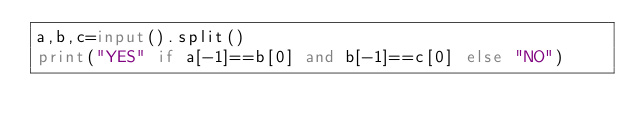<code> <loc_0><loc_0><loc_500><loc_500><_Python_>a,b,c=input().split()
print("YES" if a[-1]==b[0] and b[-1]==c[0] else "NO")</code> 